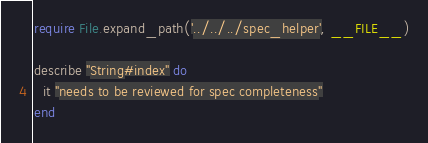<code> <loc_0><loc_0><loc_500><loc_500><_Ruby_>require File.expand_path('../../../spec_helper', __FILE__)

describe "String#index" do
  it "needs to be reviewed for spec completeness"
end
</code> 